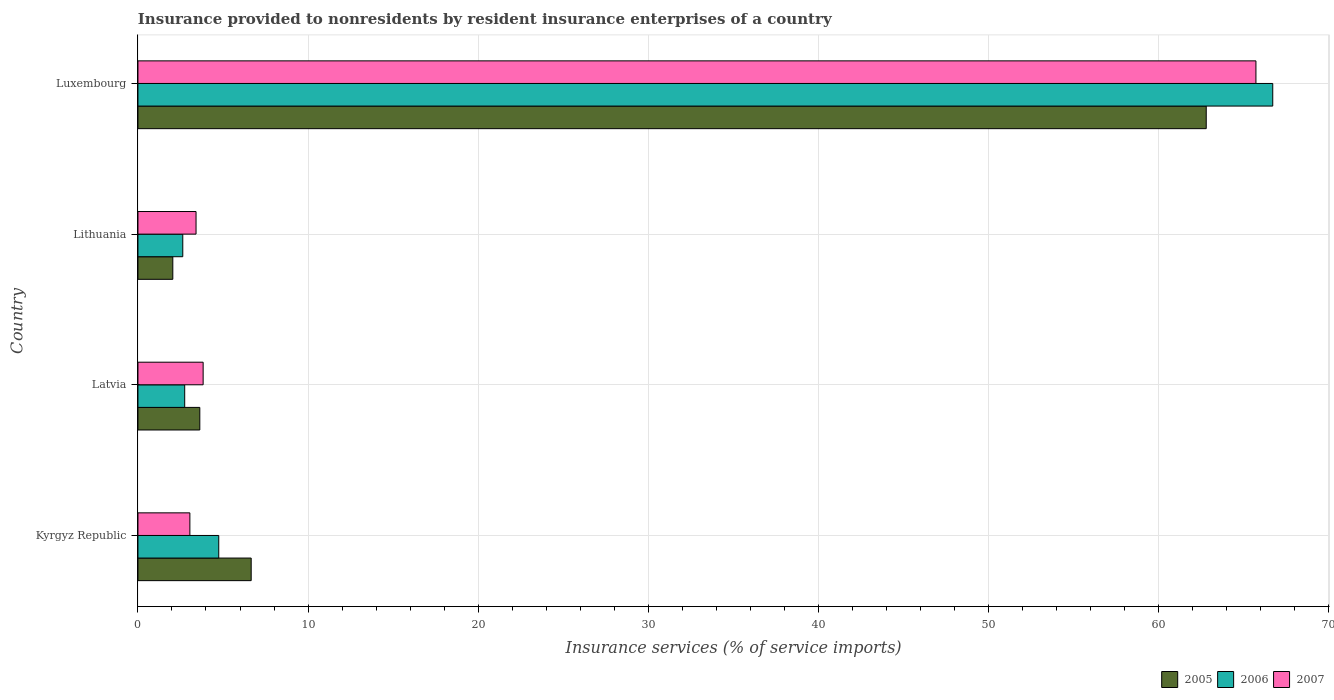How many bars are there on the 4th tick from the top?
Provide a short and direct response. 3. What is the label of the 4th group of bars from the top?
Make the answer very short. Kyrgyz Republic. What is the insurance provided to nonresidents in 2007 in Luxembourg?
Your response must be concise. 65.74. Across all countries, what is the maximum insurance provided to nonresidents in 2005?
Your answer should be compact. 62.82. Across all countries, what is the minimum insurance provided to nonresidents in 2007?
Keep it short and to the point. 3.05. In which country was the insurance provided to nonresidents in 2005 maximum?
Offer a very short reply. Luxembourg. In which country was the insurance provided to nonresidents in 2006 minimum?
Keep it short and to the point. Lithuania. What is the total insurance provided to nonresidents in 2005 in the graph?
Ensure brevity in your answer.  75.16. What is the difference between the insurance provided to nonresidents in 2006 in Kyrgyz Republic and that in Luxembourg?
Give a very brief answer. -61.98. What is the difference between the insurance provided to nonresidents in 2006 in Kyrgyz Republic and the insurance provided to nonresidents in 2005 in Latvia?
Your answer should be very brief. 1.11. What is the average insurance provided to nonresidents in 2007 per country?
Give a very brief answer. 19.01. What is the difference between the insurance provided to nonresidents in 2005 and insurance provided to nonresidents in 2006 in Luxembourg?
Provide a short and direct response. -3.91. In how many countries, is the insurance provided to nonresidents in 2007 greater than 8 %?
Make the answer very short. 1. What is the ratio of the insurance provided to nonresidents in 2007 in Latvia to that in Lithuania?
Give a very brief answer. 1.12. Is the insurance provided to nonresidents in 2005 in Latvia less than that in Lithuania?
Ensure brevity in your answer.  No. Is the difference between the insurance provided to nonresidents in 2005 in Latvia and Lithuania greater than the difference between the insurance provided to nonresidents in 2006 in Latvia and Lithuania?
Give a very brief answer. Yes. What is the difference between the highest and the second highest insurance provided to nonresidents in 2006?
Your answer should be compact. 61.98. What is the difference between the highest and the lowest insurance provided to nonresidents in 2006?
Offer a terse response. 64.09. In how many countries, is the insurance provided to nonresidents in 2006 greater than the average insurance provided to nonresidents in 2006 taken over all countries?
Your response must be concise. 1. Is the sum of the insurance provided to nonresidents in 2006 in Kyrgyz Republic and Latvia greater than the maximum insurance provided to nonresidents in 2005 across all countries?
Provide a succinct answer. No. What does the 3rd bar from the top in Luxembourg represents?
Your answer should be compact. 2005. Is it the case that in every country, the sum of the insurance provided to nonresidents in 2006 and insurance provided to nonresidents in 2007 is greater than the insurance provided to nonresidents in 2005?
Provide a short and direct response. Yes. Are all the bars in the graph horizontal?
Keep it short and to the point. Yes. How many countries are there in the graph?
Provide a succinct answer. 4. Are the values on the major ticks of X-axis written in scientific E-notation?
Your answer should be very brief. No. Does the graph contain any zero values?
Your response must be concise. No. Where does the legend appear in the graph?
Offer a very short reply. Bottom right. How many legend labels are there?
Offer a terse response. 3. What is the title of the graph?
Your answer should be compact. Insurance provided to nonresidents by resident insurance enterprises of a country. What is the label or title of the X-axis?
Your response must be concise. Insurance services (% of service imports). What is the Insurance services (% of service imports) in 2005 in Kyrgyz Republic?
Provide a short and direct response. 6.66. What is the Insurance services (% of service imports) of 2006 in Kyrgyz Republic?
Offer a terse response. 4.75. What is the Insurance services (% of service imports) in 2007 in Kyrgyz Republic?
Offer a terse response. 3.05. What is the Insurance services (% of service imports) of 2005 in Latvia?
Give a very brief answer. 3.64. What is the Insurance services (% of service imports) in 2006 in Latvia?
Ensure brevity in your answer.  2.75. What is the Insurance services (% of service imports) of 2007 in Latvia?
Keep it short and to the point. 3.83. What is the Insurance services (% of service imports) of 2005 in Lithuania?
Keep it short and to the point. 2.05. What is the Insurance services (% of service imports) of 2006 in Lithuania?
Provide a succinct answer. 2.64. What is the Insurance services (% of service imports) of 2007 in Lithuania?
Offer a terse response. 3.42. What is the Insurance services (% of service imports) in 2005 in Luxembourg?
Offer a very short reply. 62.82. What is the Insurance services (% of service imports) in 2006 in Luxembourg?
Your answer should be compact. 66.73. What is the Insurance services (% of service imports) in 2007 in Luxembourg?
Your response must be concise. 65.74. Across all countries, what is the maximum Insurance services (% of service imports) in 2005?
Keep it short and to the point. 62.82. Across all countries, what is the maximum Insurance services (% of service imports) of 2006?
Your answer should be very brief. 66.73. Across all countries, what is the maximum Insurance services (% of service imports) in 2007?
Provide a succinct answer. 65.74. Across all countries, what is the minimum Insurance services (% of service imports) of 2005?
Give a very brief answer. 2.05. Across all countries, what is the minimum Insurance services (% of service imports) of 2006?
Make the answer very short. 2.64. Across all countries, what is the minimum Insurance services (% of service imports) in 2007?
Provide a short and direct response. 3.05. What is the total Insurance services (% of service imports) of 2005 in the graph?
Your answer should be very brief. 75.16. What is the total Insurance services (% of service imports) of 2006 in the graph?
Your answer should be compact. 76.87. What is the total Insurance services (% of service imports) of 2007 in the graph?
Ensure brevity in your answer.  76.04. What is the difference between the Insurance services (% of service imports) in 2005 in Kyrgyz Republic and that in Latvia?
Your response must be concise. 3.02. What is the difference between the Insurance services (% of service imports) of 2006 in Kyrgyz Republic and that in Latvia?
Provide a short and direct response. 2. What is the difference between the Insurance services (% of service imports) of 2007 in Kyrgyz Republic and that in Latvia?
Give a very brief answer. -0.78. What is the difference between the Insurance services (% of service imports) in 2005 in Kyrgyz Republic and that in Lithuania?
Give a very brief answer. 4.61. What is the difference between the Insurance services (% of service imports) of 2006 in Kyrgyz Republic and that in Lithuania?
Provide a succinct answer. 2.11. What is the difference between the Insurance services (% of service imports) of 2007 in Kyrgyz Republic and that in Lithuania?
Your answer should be compact. -0.36. What is the difference between the Insurance services (% of service imports) in 2005 in Kyrgyz Republic and that in Luxembourg?
Give a very brief answer. -56.16. What is the difference between the Insurance services (% of service imports) of 2006 in Kyrgyz Republic and that in Luxembourg?
Offer a terse response. -61.98. What is the difference between the Insurance services (% of service imports) of 2007 in Kyrgyz Republic and that in Luxembourg?
Your answer should be very brief. -62.69. What is the difference between the Insurance services (% of service imports) in 2005 in Latvia and that in Lithuania?
Offer a very short reply. 1.59. What is the difference between the Insurance services (% of service imports) in 2006 in Latvia and that in Lithuania?
Give a very brief answer. 0.11. What is the difference between the Insurance services (% of service imports) in 2007 in Latvia and that in Lithuania?
Keep it short and to the point. 0.42. What is the difference between the Insurance services (% of service imports) in 2005 in Latvia and that in Luxembourg?
Provide a succinct answer. -59.18. What is the difference between the Insurance services (% of service imports) of 2006 in Latvia and that in Luxembourg?
Ensure brevity in your answer.  -63.98. What is the difference between the Insurance services (% of service imports) of 2007 in Latvia and that in Luxembourg?
Your response must be concise. -61.91. What is the difference between the Insurance services (% of service imports) in 2005 in Lithuania and that in Luxembourg?
Make the answer very short. -60.77. What is the difference between the Insurance services (% of service imports) of 2006 in Lithuania and that in Luxembourg?
Make the answer very short. -64.09. What is the difference between the Insurance services (% of service imports) in 2007 in Lithuania and that in Luxembourg?
Your answer should be very brief. -62.33. What is the difference between the Insurance services (% of service imports) in 2005 in Kyrgyz Republic and the Insurance services (% of service imports) in 2006 in Latvia?
Offer a very short reply. 3.91. What is the difference between the Insurance services (% of service imports) in 2005 in Kyrgyz Republic and the Insurance services (% of service imports) in 2007 in Latvia?
Make the answer very short. 2.83. What is the difference between the Insurance services (% of service imports) of 2006 in Kyrgyz Republic and the Insurance services (% of service imports) of 2007 in Latvia?
Offer a very short reply. 0.92. What is the difference between the Insurance services (% of service imports) of 2005 in Kyrgyz Republic and the Insurance services (% of service imports) of 2006 in Lithuania?
Offer a terse response. 4.02. What is the difference between the Insurance services (% of service imports) of 2005 in Kyrgyz Republic and the Insurance services (% of service imports) of 2007 in Lithuania?
Provide a succinct answer. 3.24. What is the difference between the Insurance services (% of service imports) of 2006 in Kyrgyz Republic and the Insurance services (% of service imports) of 2007 in Lithuania?
Your response must be concise. 1.34. What is the difference between the Insurance services (% of service imports) of 2005 in Kyrgyz Republic and the Insurance services (% of service imports) of 2006 in Luxembourg?
Your response must be concise. -60.07. What is the difference between the Insurance services (% of service imports) of 2005 in Kyrgyz Republic and the Insurance services (% of service imports) of 2007 in Luxembourg?
Give a very brief answer. -59.08. What is the difference between the Insurance services (% of service imports) in 2006 in Kyrgyz Republic and the Insurance services (% of service imports) in 2007 in Luxembourg?
Your answer should be very brief. -60.99. What is the difference between the Insurance services (% of service imports) in 2005 in Latvia and the Insurance services (% of service imports) in 2006 in Lithuania?
Your answer should be very brief. 1. What is the difference between the Insurance services (% of service imports) in 2005 in Latvia and the Insurance services (% of service imports) in 2007 in Lithuania?
Your response must be concise. 0.22. What is the difference between the Insurance services (% of service imports) of 2005 in Latvia and the Insurance services (% of service imports) of 2006 in Luxembourg?
Provide a short and direct response. -63.09. What is the difference between the Insurance services (% of service imports) in 2005 in Latvia and the Insurance services (% of service imports) in 2007 in Luxembourg?
Provide a short and direct response. -62.1. What is the difference between the Insurance services (% of service imports) in 2006 in Latvia and the Insurance services (% of service imports) in 2007 in Luxembourg?
Keep it short and to the point. -62.99. What is the difference between the Insurance services (% of service imports) of 2005 in Lithuania and the Insurance services (% of service imports) of 2006 in Luxembourg?
Your answer should be very brief. -64.68. What is the difference between the Insurance services (% of service imports) in 2005 in Lithuania and the Insurance services (% of service imports) in 2007 in Luxembourg?
Give a very brief answer. -63.69. What is the difference between the Insurance services (% of service imports) in 2006 in Lithuania and the Insurance services (% of service imports) in 2007 in Luxembourg?
Offer a terse response. -63.1. What is the average Insurance services (% of service imports) of 2005 per country?
Ensure brevity in your answer.  18.79. What is the average Insurance services (% of service imports) in 2006 per country?
Offer a terse response. 19.22. What is the average Insurance services (% of service imports) in 2007 per country?
Make the answer very short. 19.01. What is the difference between the Insurance services (% of service imports) of 2005 and Insurance services (% of service imports) of 2006 in Kyrgyz Republic?
Offer a very short reply. 1.91. What is the difference between the Insurance services (% of service imports) in 2005 and Insurance services (% of service imports) in 2007 in Kyrgyz Republic?
Your answer should be compact. 3.61. What is the difference between the Insurance services (% of service imports) in 2006 and Insurance services (% of service imports) in 2007 in Kyrgyz Republic?
Your answer should be compact. 1.7. What is the difference between the Insurance services (% of service imports) in 2005 and Insurance services (% of service imports) in 2006 in Latvia?
Keep it short and to the point. 0.89. What is the difference between the Insurance services (% of service imports) of 2005 and Insurance services (% of service imports) of 2007 in Latvia?
Provide a succinct answer. -0.2. What is the difference between the Insurance services (% of service imports) of 2006 and Insurance services (% of service imports) of 2007 in Latvia?
Your answer should be compact. -1.08. What is the difference between the Insurance services (% of service imports) in 2005 and Insurance services (% of service imports) in 2006 in Lithuania?
Make the answer very short. -0.59. What is the difference between the Insurance services (% of service imports) in 2005 and Insurance services (% of service imports) in 2007 in Lithuania?
Your answer should be very brief. -1.37. What is the difference between the Insurance services (% of service imports) in 2006 and Insurance services (% of service imports) in 2007 in Lithuania?
Ensure brevity in your answer.  -0.78. What is the difference between the Insurance services (% of service imports) in 2005 and Insurance services (% of service imports) in 2006 in Luxembourg?
Keep it short and to the point. -3.91. What is the difference between the Insurance services (% of service imports) of 2005 and Insurance services (% of service imports) of 2007 in Luxembourg?
Give a very brief answer. -2.92. What is the ratio of the Insurance services (% of service imports) in 2005 in Kyrgyz Republic to that in Latvia?
Provide a short and direct response. 1.83. What is the ratio of the Insurance services (% of service imports) of 2006 in Kyrgyz Republic to that in Latvia?
Offer a very short reply. 1.73. What is the ratio of the Insurance services (% of service imports) of 2007 in Kyrgyz Republic to that in Latvia?
Ensure brevity in your answer.  0.8. What is the ratio of the Insurance services (% of service imports) of 2005 in Kyrgyz Republic to that in Lithuania?
Your answer should be compact. 3.25. What is the ratio of the Insurance services (% of service imports) of 2006 in Kyrgyz Republic to that in Lithuania?
Your response must be concise. 1.8. What is the ratio of the Insurance services (% of service imports) of 2007 in Kyrgyz Republic to that in Lithuania?
Offer a very short reply. 0.89. What is the ratio of the Insurance services (% of service imports) in 2005 in Kyrgyz Republic to that in Luxembourg?
Ensure brevity in your answer.  0.11. What is the ratio of the Insurance services (% of service imports) of 2006 in Kyrgyz Republic to that in Luxembourg?
Keep it short and to the point. 0.07. What is the ratio of the Insurance services (% of service imports) in 2007 in Kyrgyz Republic to that in Luxembourg?
Your response must be concise. 0.05. What is the ratio of the Insurance services (% of service imports) of 2005 in Latvia to that in Lithuania?
Your response must be concise. 1.77. What is the ratio of the Insurance services (% of service imports) of 2006 in Latvia to that in Lithuania?
Offer a very short reply. 1.04. What is the ratio of the Insurance services (% of service imports) in 2007 in Latvia to that in Lithuania?
Your response must be concise. 1.12. What is the ratio of the Insurance services (% of service imports) of 2005 in Latvia to that in Luxembourg?
Provide a short and direct response. 0.06. What is the ratio of the Insurance services (% of service imports) of 2006 in Latvia to that in Luxembourg?
Your response must be concise. 0.04. What is the ratio of the Insurance services (% of service imports) in 2007 in Latvia to that in Luxembourg?
Provide a short and direct response. 0.06. What is the ratio of the Insurance services (% of service imports) of 2005 in Lithuania to that in Luxembourg?
Your answer should be compact. 0.03. What is the ratio of the Insurance services (% of service imports) of 2006 in Lithuania to that in Luxembourg?
Offer a very short reply. 0.04. What is the ratio of the Insurance services (% of service imports) of 2007 in Lithuania to that in Luxembourg?
Provide a short and direct response. 0.05. What is the difference between the highest and the second highest Insurance services (% of service imports) of 2005?
Your response must be concise. 56.16. What is the difference between the highest and the second highest Insurance services (% of service imports) of 2006?
Ensure brevity in your answer.  61.98. What is the difference between the highest and the second highest Insurance services (% of service imports) in 2007?
Make the answer very short. 61.91. What is the difference between the highest and the lowest Insurance services (% of service imports) of 2005?
Your answer should be compact. 60.77. What is the difference between the highest and the lowest Insurance services (% of service imports) in 2006?
Provide a short and direct response. 64.09. What is the difference between the highest and the lowest Insurance services (% of service imports) of 2007?
Give a very brief answer. 62.69. 